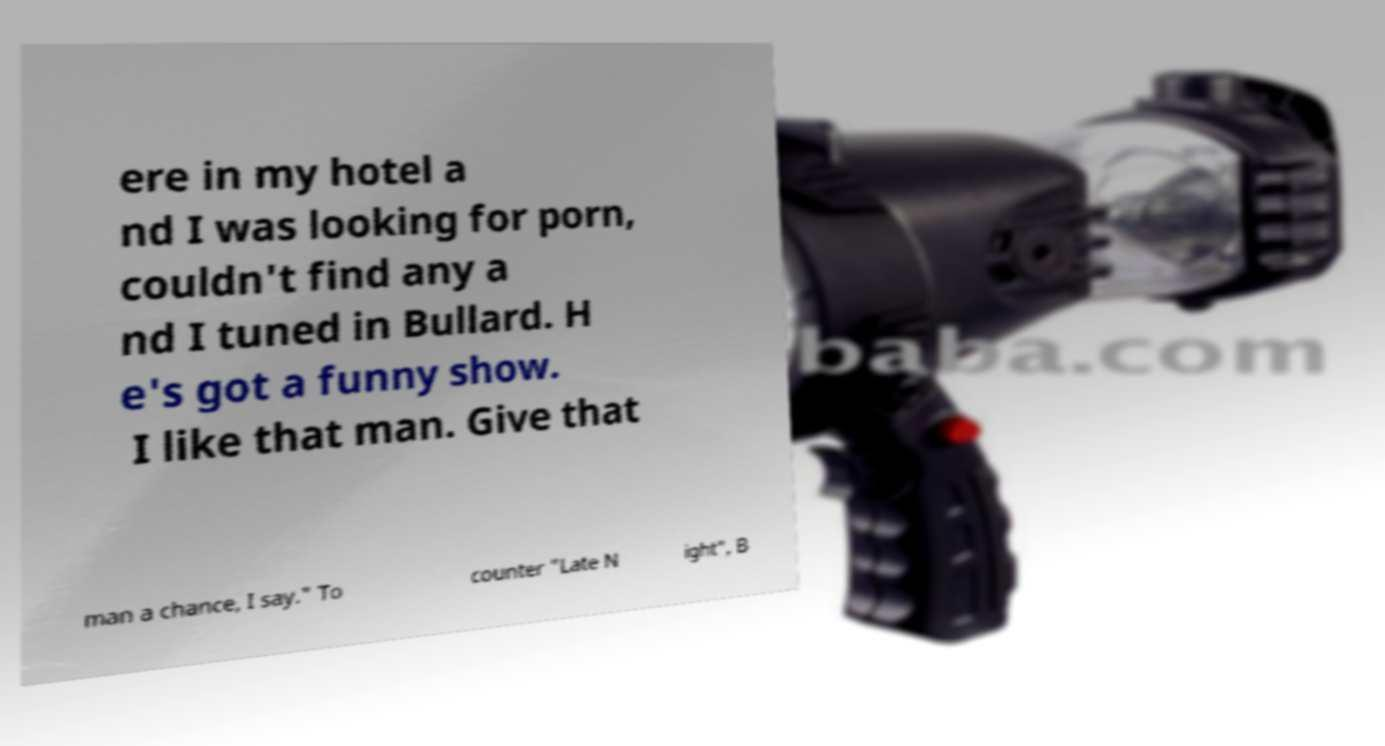For documentation purposes, I need the text within this image transcribed. Could you provide that? ere in my hotel a nd I was looking for porn, couldn't find any a nd I tuned in Bullard. H e's got a funny show. I like that man. Give that man a chance, I say." To counter "Late N ight", B 